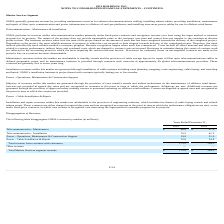According to Hc2 Holdings's financial document, What was the telecommunication - maintenance revenue in 2019? According to the financial document, $86.8 (in millions). The relevant text states: "Telecommunication - Maintenance $ 86.8 $ 87.0..." Also, What was the telecommunication - installation revenue in 2019? According to the financial document, 33.2 (in millions). The relevant text states: "Telecommunication - Installation 33.2 41.5..." Also, What was the power - operations, maintenance and construction revenue in 2019? According to the financial document, 19.9 (in millions). The relevant text states: "- Operations, Maintenance & Construction Support 19.9 31.0..." Also, can you calculate: What is the change in the telecommunication maintenance revenue from 2018 to 2019? Based on the calculation: 86.8 - 87.0, the result is -0.2 (in millions). This is based on the information: "Telecommunication - Maintenance $ 86.8 $ 87.0 Telecommunication - Maintenance $ 86.8 $ 87.0..." The key data points involved are: 86.8, 87.0. Also, can you calculate: What is the average telecommunications installation revenue for 2018 and 2019? To answer this question, I need to perform calculations using the financial data. The calculation is: (33.2 + 41.5) / 2, which equals 37.35 (in millions). This is based on the information: "Telecommunication - Installation 33.2 41.5 Telecommunication - Installation 33.2 41.5..." The key data points involved are: 33.2, 41.5. Also, can you calculate: What is the average Total Marine Services segment revenue for 2018 and 2019? To answer this question, I need to perform calculations using the financial data. The calculation is: (172.5 + 194.3) / 2, which equals 183.4 (in millions). This is based on the information: "Total revenue from contracts with customers 172.5 194.3 Total revenue from contracts with customers 172.5 194.3..." The key data points involved are: 172.5, 194.3. 